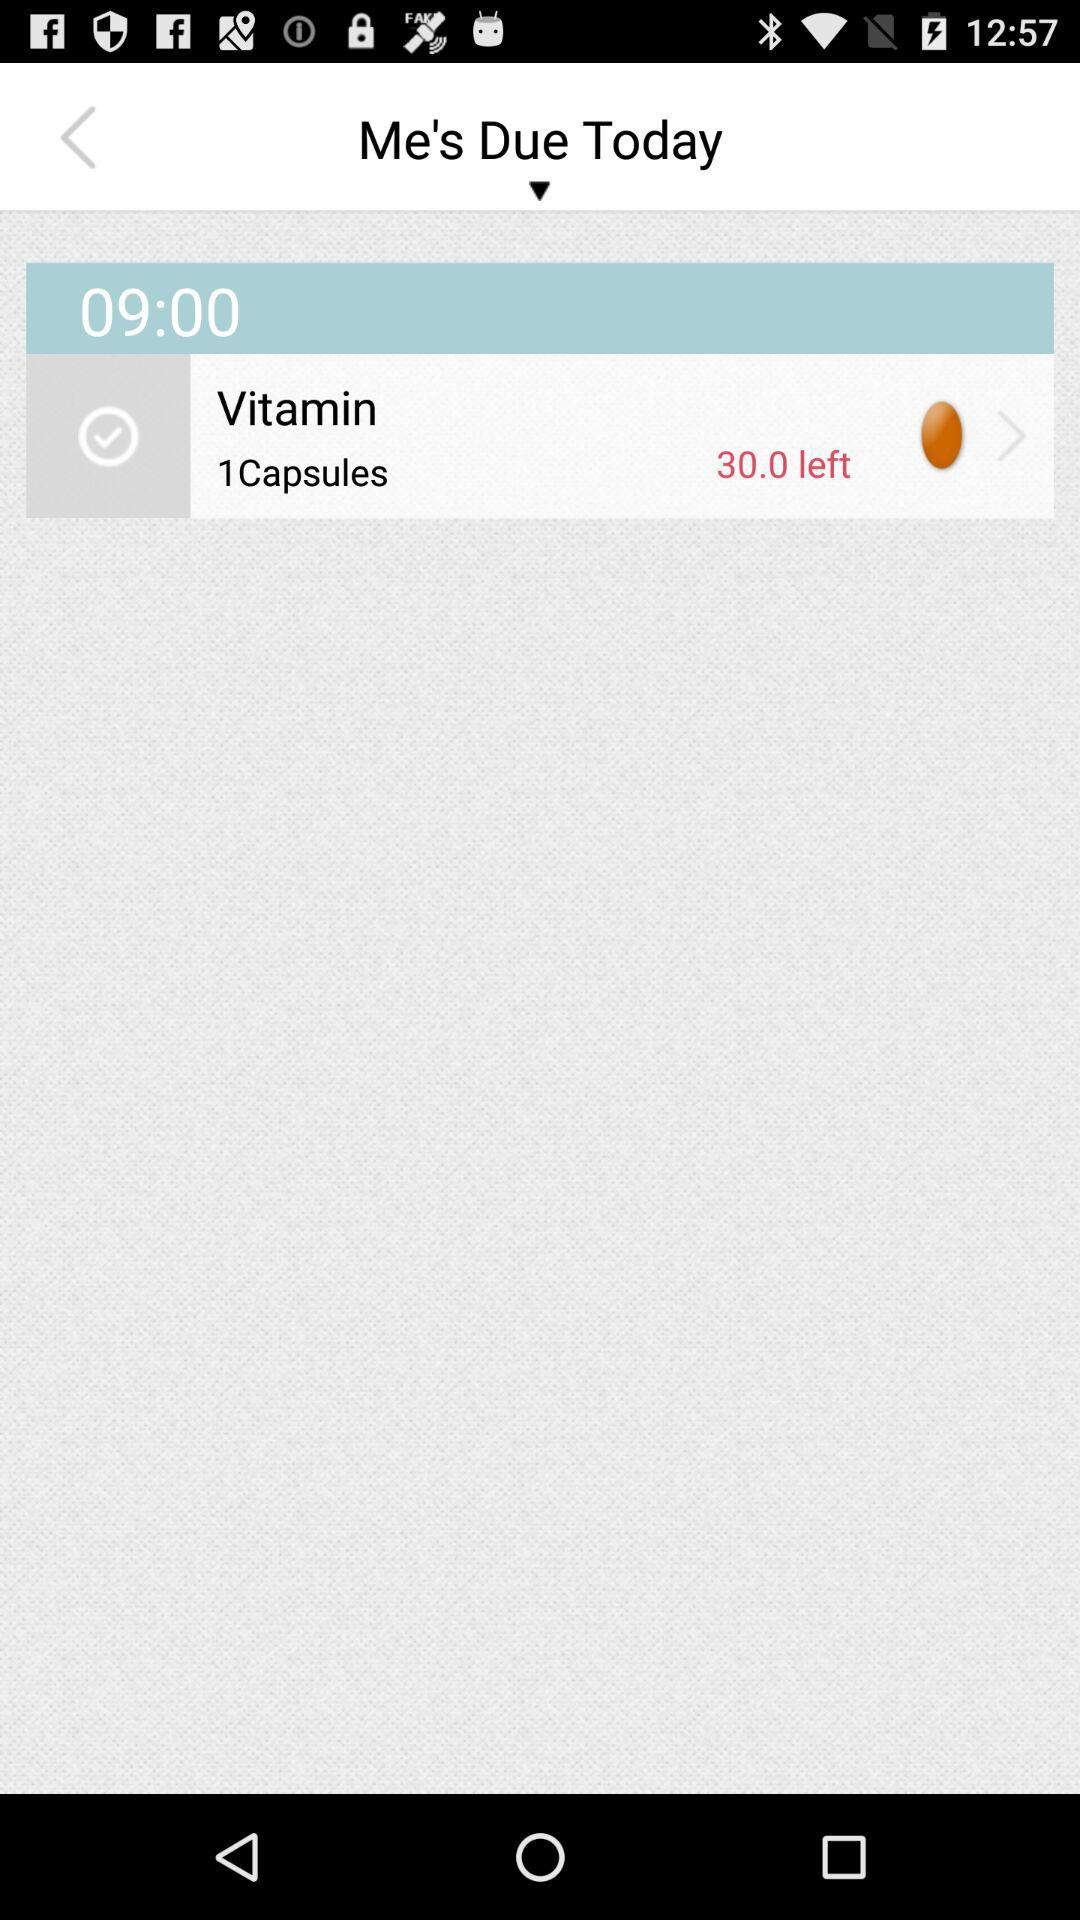How many vitamin capsules do I have to take today? You have to take 1 vitamin capsule today. 